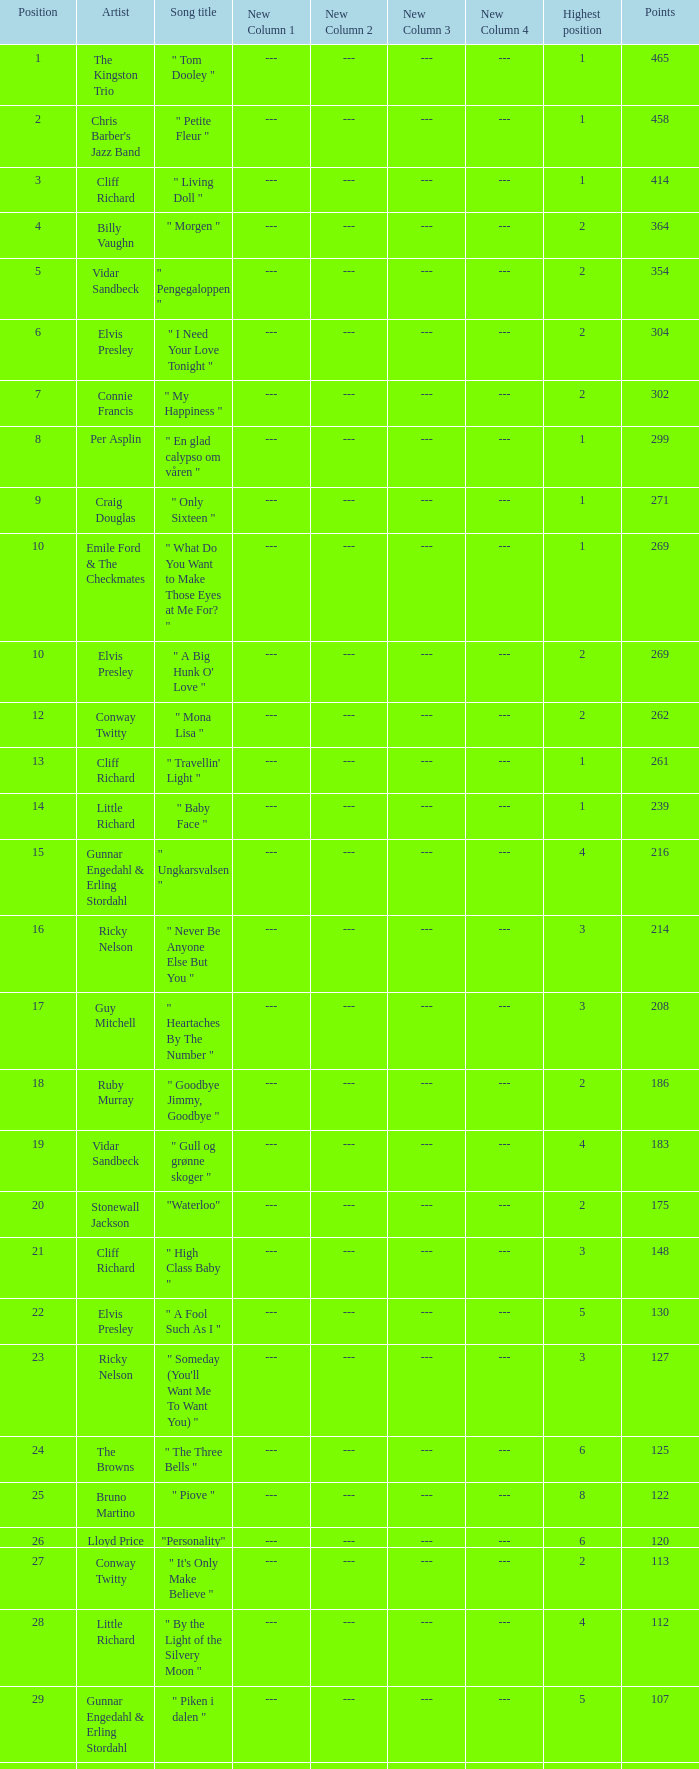Parse the table in full. {'header': ['Position', 'Artist', 'Song title', 'New Column 1', 'New Column 2', 'New Column 3', 'New Column 4', 'Highest position', 'Points'], 'rows': [['1', 'The Kingston Trio', '" Tom Dooley "', '---', '---', '---', '---', '1', '465'], ['2', "Chris Barber's Jazz Band", '" Petite Fleur "', '---', '---', '---', '---', '1', '458'], ['3', 'Cliff Richard', '" Living Doll "', '---', '---', '---', '---', '1', '414'], ['4', 'Billy Vaughn', '" Morgen "', '---', '---', '---', '---', '2', '364'], ['5', 'Vidar Sandbeck', '" Pengegaloppen "', '---', '---', '---', '---', '2', '354'], ['6', 'Elvis Presley', '" I Need Your Love Tonight "', '---', '---', '---', '---', '2', '304'], ['7', 'Connie Francis', '" My Happiness "', '---', '---', '---', '---', '2', '302'], ['8', 'Per Asplin', '" En glad calypso om våren "', '---', '---', '---', '---', '1', '299'], ['9', 'Craig Douglas', '" Only Sixteen "', '---', '---', '---', '---', '1', '271'], ['10', 'Emile Ford & The Checkmates', '" What Do You Want to Make Those Eyes at Me For? "', '---', '---', '---', '---', '1', '269'], ['10', 'Elvis Presley', '" A Big Hunk O\' Love "', '---', '---', '---', '---', '2', '269'], ['12', 'Conway Twitty', '" Mona Lisa "', '---', '---', '---', '---', '2', '262'], ['13', 'Cliff Richard', '" Travellin\' Light "', '---', '---', '---', '---', '1', '261'], ['14', 'Little Richard', '" Baby Face "', '---', '---', '---', '---', '1', '239'], ['15', 'Gunnar Engedahl & Erling Stordahl', '" Ungkarsvalsen "', '---', '---', '---', '---', '4', '216'], ['16', 'Ricky Nelson', '" Never Be Anyone Else But You "', '---', '---', '---', '---', '3', '214'], ['17', 'Guy Mitchell', '" Heartaches By The Number "', '---', '---', '---', '---', '3', '208'], ['18', 'Ruby Murray', '" Goodbye Jimmy, Goodbye "', '---', '---', '---', '---', '2', '186'], ['19', 'Vidar Sandbeck', '" Gull og grønne skoger "', '---', '---', '---', '---', '4', '183'], ['20', 'Stonewall Jackson', '"Waterloo"', '---', '---', '---', '---', '2', '175'], ['21', 'Cliff Richard', '" High Class Baby "', '---', '---', '---', '---', '3', '148'], ['22', 'Elvis Presley', '" A Fool Such As I "', '---', '---', '---', '---', '5', '130'], ['23', 'Ricky Nelson', '" Someday (You\'ll Want Me To Want You) "', '---', '---', '---', '---', '3', '127'], ['24', 'The Browns', '" The Three Bells "', '---', '---', '---', '---', '6', '125'], ['25', 'Bruno Martino', '" Piove "', '---', '---', '---', '---', '8', '122'], ['26', 'Lloyd Price', '"Personality"', '---', '---', '---', '---', '6', '120'], ['27', 'Conway Twitty', '" It\'s Only Make Believe "', '---', '---', '---', '---', '2', '113'], ['28', 'Little Richard', '" By the Light of the Silvery Moon "', '---', '---', '---', '---', '4', '112'], ['29', 'Gunnar Engedahl & Erling Stordahl', '" Piken i dalen "', '---', '---', '---', '---', '5', '107'], ['30', 'Shirley Bassey', '" Kiss Me, Honey Honey, Kiss Me "', '---', '---', '---', '---', '6', '103'], ['31', 'Bobby Darin', '" Dream Lover "', '---', '---', '---', '---', '5', '100'], ['32', 'The Fleetwoods', '" Mr. Blue "', '---', '---', '---', '---', '5', '99'], ['33', 'Cliff Richard', '" Move It "', '---', '---', '---', '---', '5', '97'], ['33', 'Nora Brockstedt', '" Augustin "', '---', '---', '---', '---', '5', '97'], ['35', 'The Coasters', '" Charlie Brown "', '---', '---', '---', '---', '5', '85'], ['36', 'Cliff Richard', '" Never Mind "', '---', '---', '---', '---', '5', '82'], ['37', 'Jerry Keller', '" Here Comes Summer "', '---', '---', '---', '---', '8', '73'], ['38', 'Connie Francis', '" Lipstick On Your Collar "', '---', '---', '---', '---', '7', '80'], ['39', 'Lloyd Price', '" Stagger Lee "', '---', '---', '---', '---', '8', '58'], ['40', 'Floyd Robinson', '" Makin\' Love "', '---', '---', '---', '---', '7', '53'], ['41', 'Jane Morgan', '" The Day The Rains Came "', '---', '---', '---', '---', '7', '49'], ['42', 'Bing Crosby', '" White Christmas "', '---', '---', '---', '---', '6', '41'], ['43', 'Paul Anka', '" Lonely Boy "', '---', '---', '---', '---', '9', '36'], ['44', 'Bobby Darin', '" Mack The Knife "', '---', '---', '---', '---', '9', '34'], ['45', 'Pat Boone', '" I\'ll Remember Tonight "', '---', '---', '---', '---', '9', '23'], ['46', 'Sam Cooke', '" Only Sixteen "', '---', '---', '---', '---', '10', '22'], ['47', 'Bruno Martino', '" Come prima "', '---', '---', '---', '---', '9', '12']]} What is the nme of the song performed by billy vaughn? " Morgen ". 